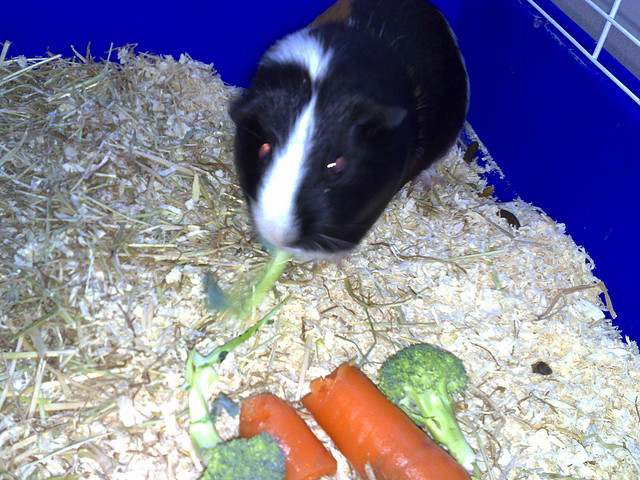Besides broccoli, what other vegetables are present in the image? Besides the two broccolis, there are also two orange carrots laid out in front of the guinea pig. 